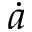<formula> <loc_0><loc_0><loc_500><loc_500>\dot { a }</formula> 